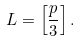Convert formula to latex. <formula><loc_0><loc_0><loc_500><loc_500>L = \left [ \frac { p } { 3 } \right ] .</formula> 